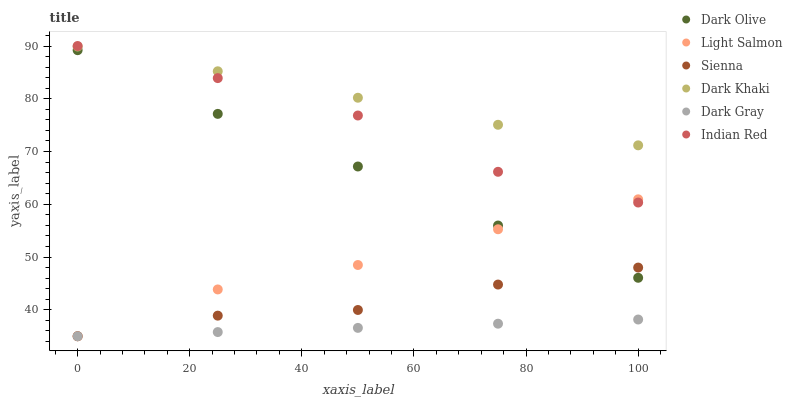Does Dark Gray have the minimum area under the curve?
Answer yes or no. Yes. Does Dark Khaki have the maximum area under the curve?
Answer yes or no. Yes. Does Light Salmon have the minimum area under the curve?
Answer yes or no. No. Does Light Salmon have the maximum area under the curve?
Answer yes or no. No. Is Dark Gray the smoothest?
Answer yes or no. Yes. Is Indian Red the roughest?
Answer yes or no. Yes. Is Light Salmon the smoothest?
Answer yes or no. No. Is Light Salmon the roughest?
Answer yes or no. No. Does Light Salmon have the lowest value?
Answer yes or no. Yes. Does Dark Olive have the lowest value?
Answer yes or no. No. Does Indian Red have the highest value?
Answer yes or no. Yes. Does Light Salmon have the highest value?
Answer yes or no. No. Is Dark Gray less than Dark Khaki?
Answer yes or no. Yes. Is Dark Olive greater than Dark Gray?
Answer yes or no. Yes. Does Sienna intersect Light Salmon?
Answer yes or no. Yes. Is Sienna less than Light Salmon?
Answer yes or no. No. Is Sienna greater than Light Salmon?
Answer yes or no. No. Does Dark Gray intersect Dark Khaki?
Answer yes or no. No. 